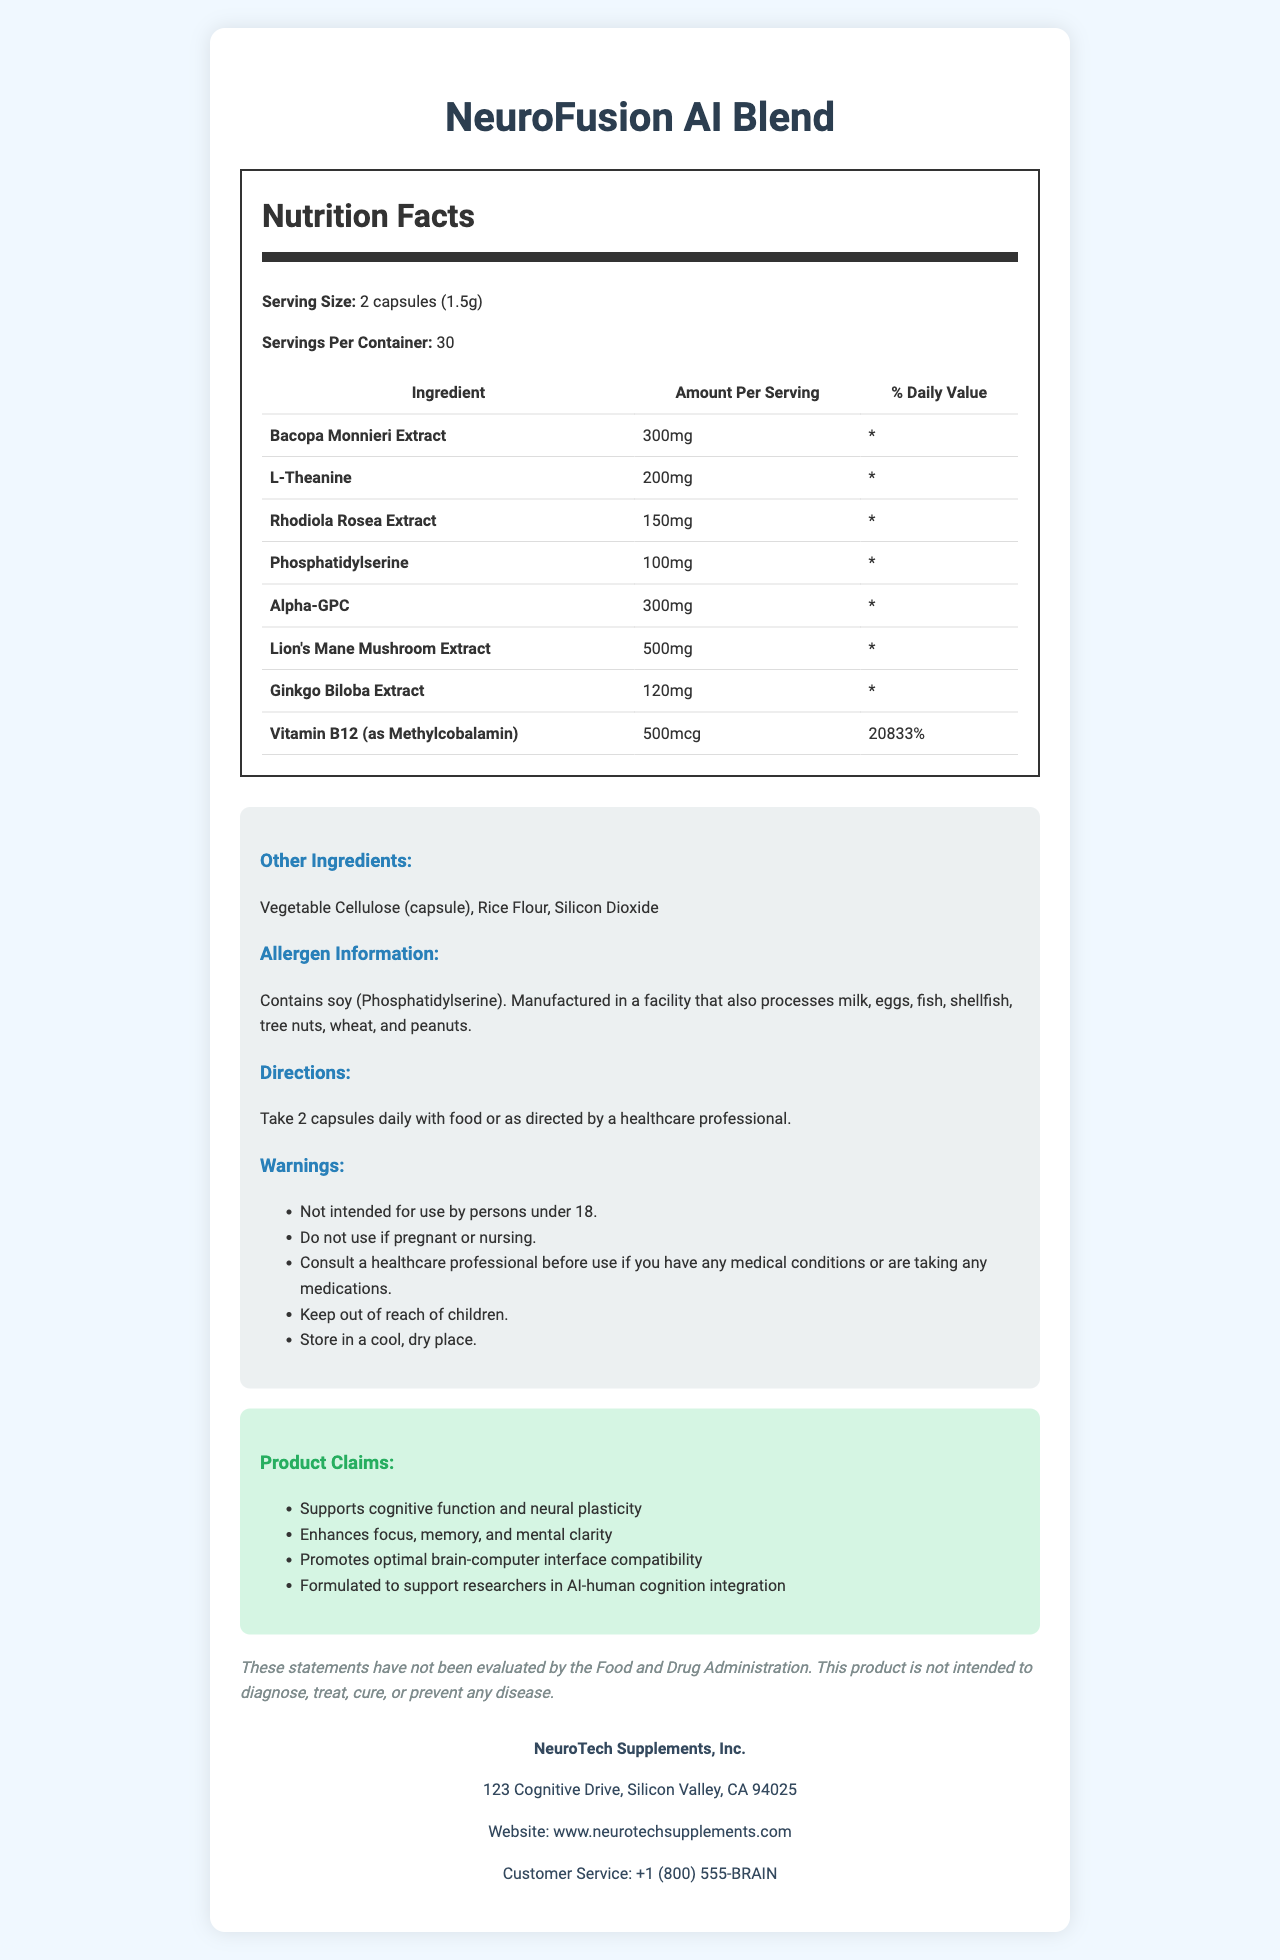how many capsules are in one serving? The serving size is listed as "2 capsules (1.5g)".
Answer: 2 capsules what ingredient has the highest amount per serving? The Lion's Mane Mushroom Extract has the highest amount per serving, which is 500mg.
Answer: Lion's Mane Mushroom Extract how should the supplement be taken? The directions specify taking the supplement daily with food or as directed by a professional.
Answer: Take 2 capsules daily with food or as directed by a healthcare professional are there any allergens in the supplement? The allergen information states that the product contains soy (Phosphatidylserine) and is manufactured in a facility that processes various allergens.
Answer: Yes which ingredient supports nerve growth factor production? The benefit of the Lion's Mane Mushroom Extract is explicitly stated as supporting nerve growth factor production.
Answer: Lion's Mane Mushroom Extract what is the manufacturer’s contact information? The customer service contact information is listed directly on the document.
Answer: +1 (800) 555-BRAIN which ingredient improves blood flow to the brain? The benefit of Ginkgo Biloba Extract is listed as improving blood flow to the brain.
Answer: Ginkgo Biloba Extract what is the primary benefit of Bacopa Monnieri Extract? The document specifies that Bacopa Monnieri Extract supports memory and cognitive function.
Answer: Supports memory and cognitive function who should not use this supplement? The warnings section specifies that the product is not intended for use by persons under 18 or those who are pregnant or nursing.
Answer: Persons under 18, pregnant or nursing individuals what is the percentage of the daily value for Vitamin B12 in one serving? The document lists the daily value percentage for Vitamin B12 (as Methylcobalamin) as 20833%.
Answer: 20833% what is the main product claim? This is one of the key product claims listed in the product claims section.
Answer: Supports cognitive function and neural plasticity which ingredient promotes relaxation and focus? According to the document, L-Theanine promotes relaxation and focus.
Answer: L-Theanine what is the serving size of NeuroFusion AI Blend? The serving size is 2 capsules, which equals 1.5g.
Answer: 1.5g what is the company's website? The document states the company's website as www.neurotechsupplements.com.
Answer: www.neurotechsupplements.com Based on the document, which of the following ingredients is NOT part of the NeuroFusion AI Blend? A. Bacopa Monnieri Extract B. Rhodiola Rosea Extract C. Caffeine Caffeine is not listed among the ingredients in the supplement.
Answer: C. Caffeine Which ingredient has the second-highest amount per serving? A. Bacopa Monnieri Extract B. Lion's Mane Mushroom Extract C. Alpha-GPC D. Vitamin B12 Bacopa Monnieri Extract has 300mg, which is the second-highest amount after Lion's Mane Mushroom Extract.
Answer: A. Bacopa Monnieri Extract Does NeuroFusion AI Blend contain any fish allergens? The allergen information specifies soy but does not mention any fish allergens.
Answer: No Please summarize the main benefits of the ingredients in NeuroFusion AI Blend. The document outlines specific benefits for each ingredient, which together contribute to the primary cognitive and mental benefits of the supplement.
Answer: The ingredients in NeuroFusion AI Blend collectively support memory, cognitive function, relaxation, focus, mental performance under stress, neural health, and blood flow to the brain. What is the exact address of the manufacturer? The address is listed at the bottom of the document under company information.
Answer: 123 Cognitive Drive, Silicon Valley, CA 94025 How does the product support researchers in AI-human cognition integration? The product claims include supporting cognitive function, neural plasticity, and brain-computer interface compatibility, which are beneficial for researchers in AI-human cognition integration.
Answer: The product is formulated to enhance cognitive function and neural plasticity, potentially facilitating brain-computer interface compatibility. What is the scientific basis for the benefits of the ingredients listed in the document? The document lists the benefits of each ingredient but does not provide the underlying scientific research or studies to back these claims.
Answer: Not enough information 